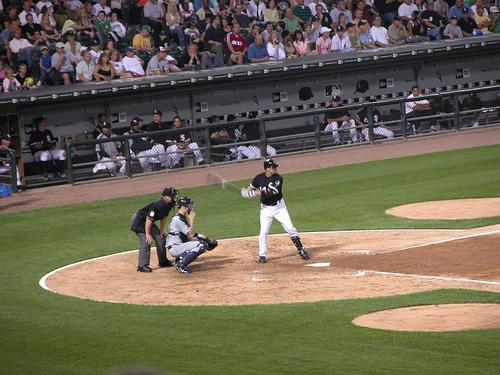How many red shirts are there?
Give a very brief answer. 1. Are there more spectators or players?
Be succinct. Spectators. What color shirt is the umpire wearing?
Concise answer only. Black. What is the standing player wearing on his lower left leg?
Keep it brief. Shin guard. 